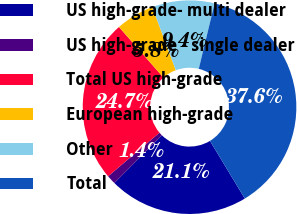Convert chart to OTSL. <chart><loc_0><loc_0><loc_500><loc_500><pie_chart><fcel>US high-grade- multi dealer<fcel>US high-grade - single dealer<fcel>Total US high-grade<fcel>European high-grade<fcel>Other<fcel>Total<nl><fcel>21.09%<fcel>1.37%<fcel>24.71%<fcel>5.82%<fcel>9.44%<fcel>37.57%<nl></chart> 